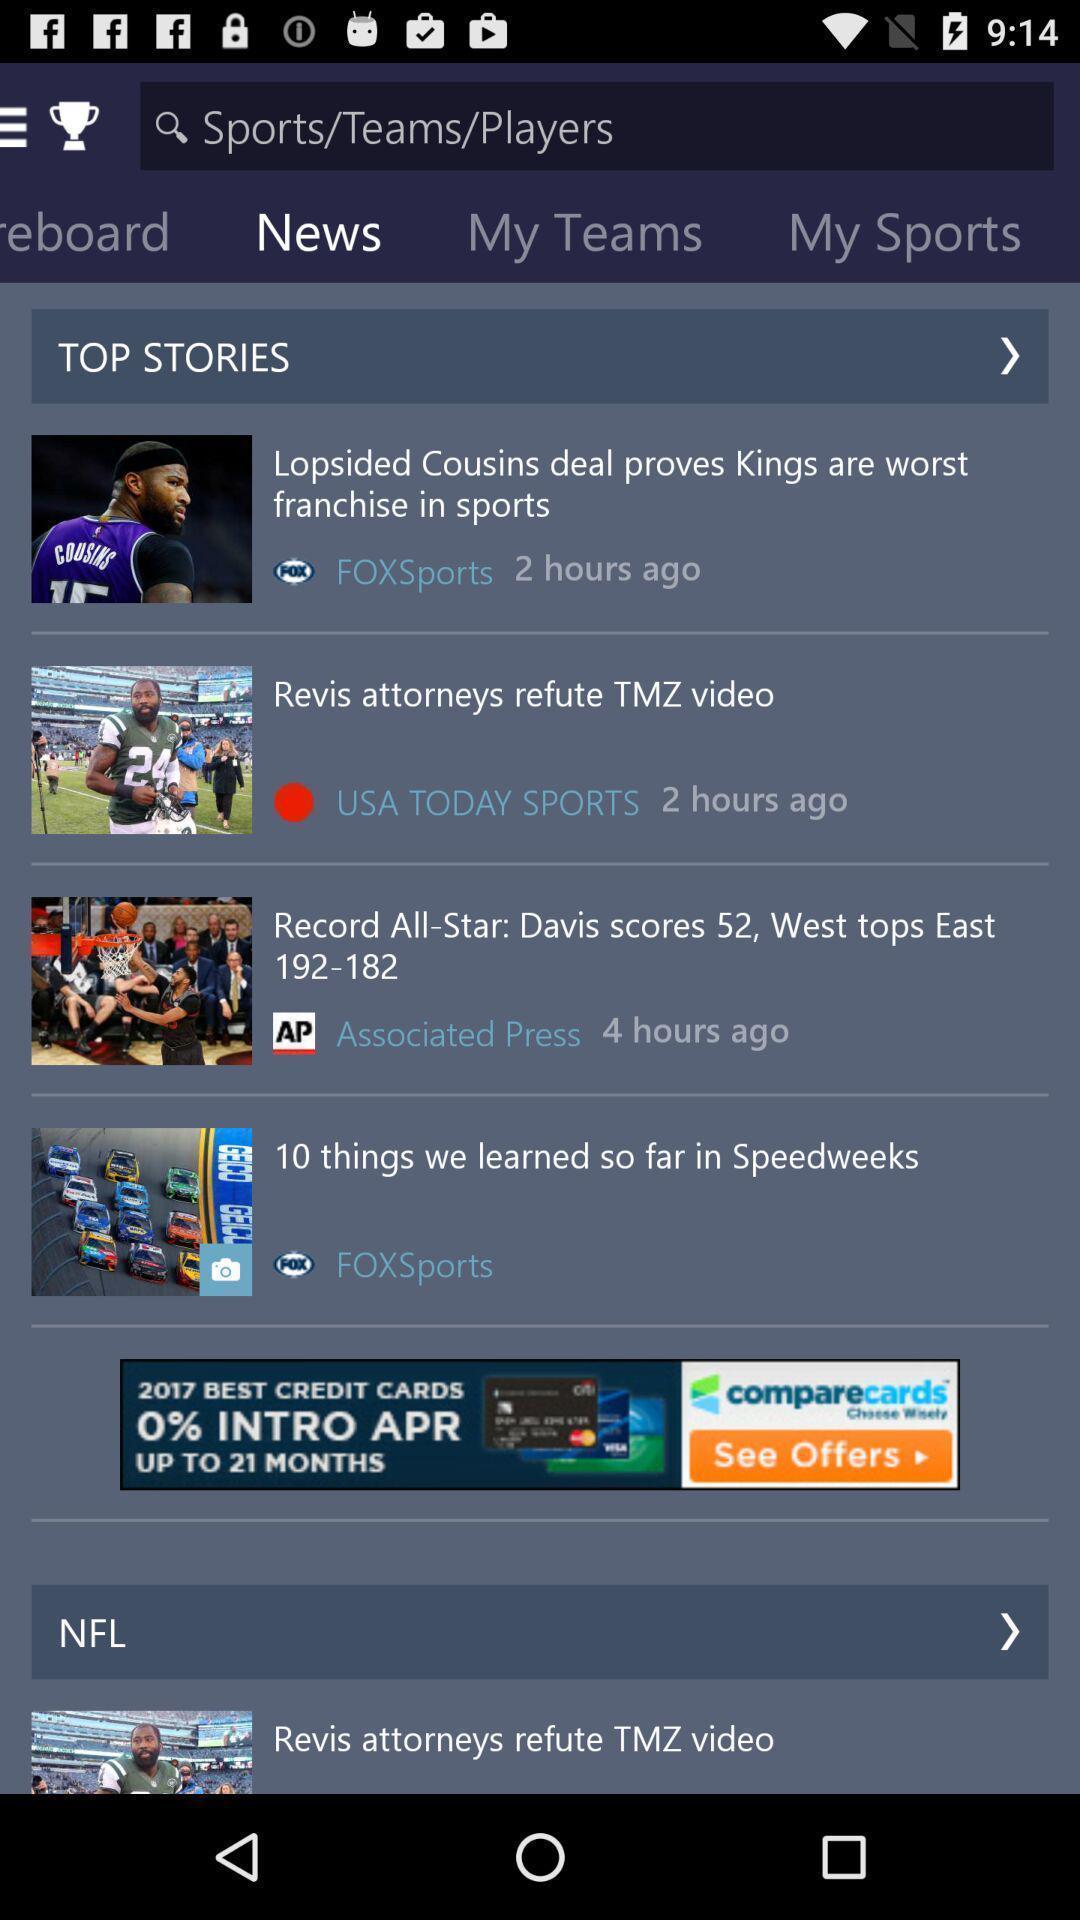Summarize the main components in this picture. Screen displaying the news page. 